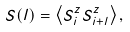Convert formula to latex. <formula><loc_0><loc_0><loc_500><loc_500>S ( l ) = \left \langle S ^ { z } _ { i } S ^ { z } _ { i + l } \right \rangle ,</formula> 